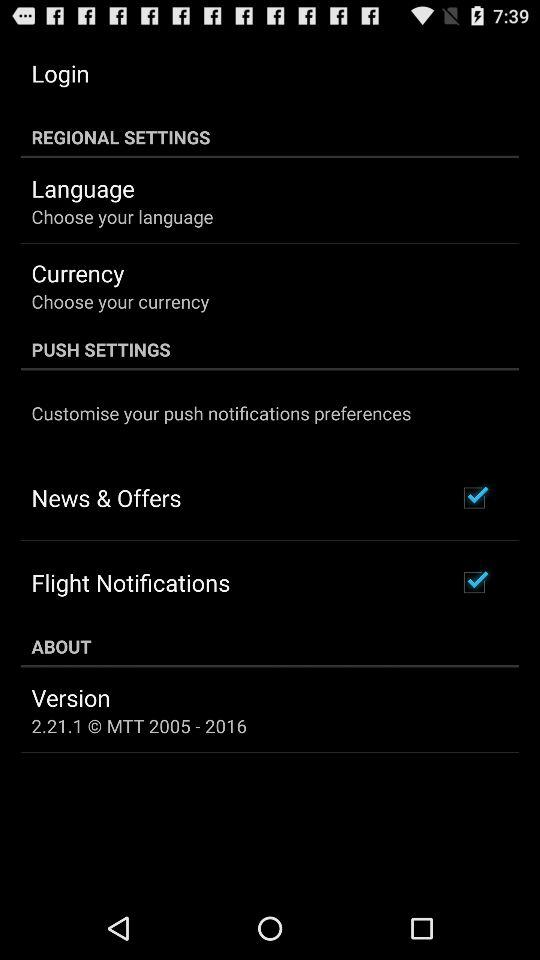What is the current version? The current version is 2.21.1. 